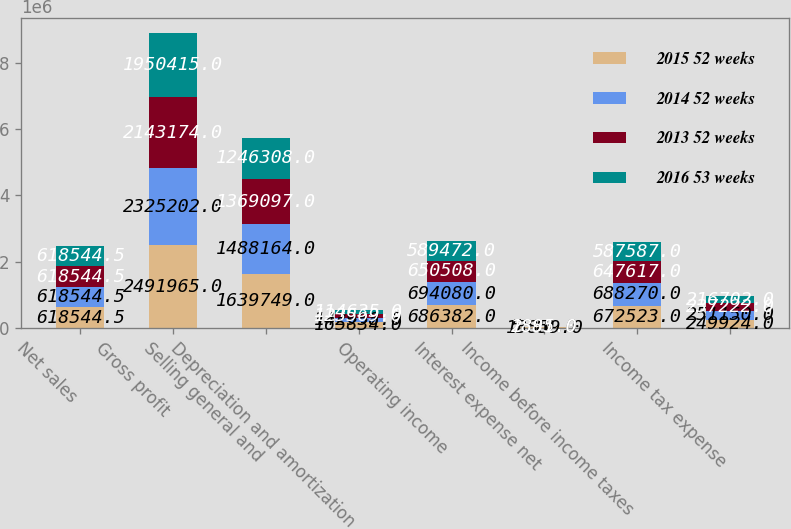<chart> <loc_0><loc_0><loc_500><loc_500><stacked_bar_chart><ecel><fcel>Net sales<fcel>Gross profit<fcel>Selling general and<fcel>Depreciation and amortization<fcel>Operating income<fcel>Interest expense net<fcel>Income before income taxes<fcel>Income tax expense<nl><fcel>2015 52 weeks<fcel>618544<fcel>2.49196e+06<fcel>1.63975e+06<fcel>165834<fcel>686382<fcel>13859<fcel>672523<fcel>249924<nl><fcel>2014 52 weeks<fcel>618544<fcel>2.3252e+06<fcel>1.48816e+06<fcel>142958<fcel>694080<fcel>5810<fcel>688270<fcel>251150<nl><fcel>2013 52 weeks<fcel>618544<fcel>2.14317e+06<fcel>1.3691e+06<fcel>123569<fcel>650508<fcel>2891<fcel>647617<fcel>237222<nl><fcel>2016 53 weeks<fcel>618544<fcel>1.95042e+06<fcel>1.24631e+06<fcel>114635<fcel>589472<fcel>1885<fcel>587587<fcel>216702<nl></chart> 